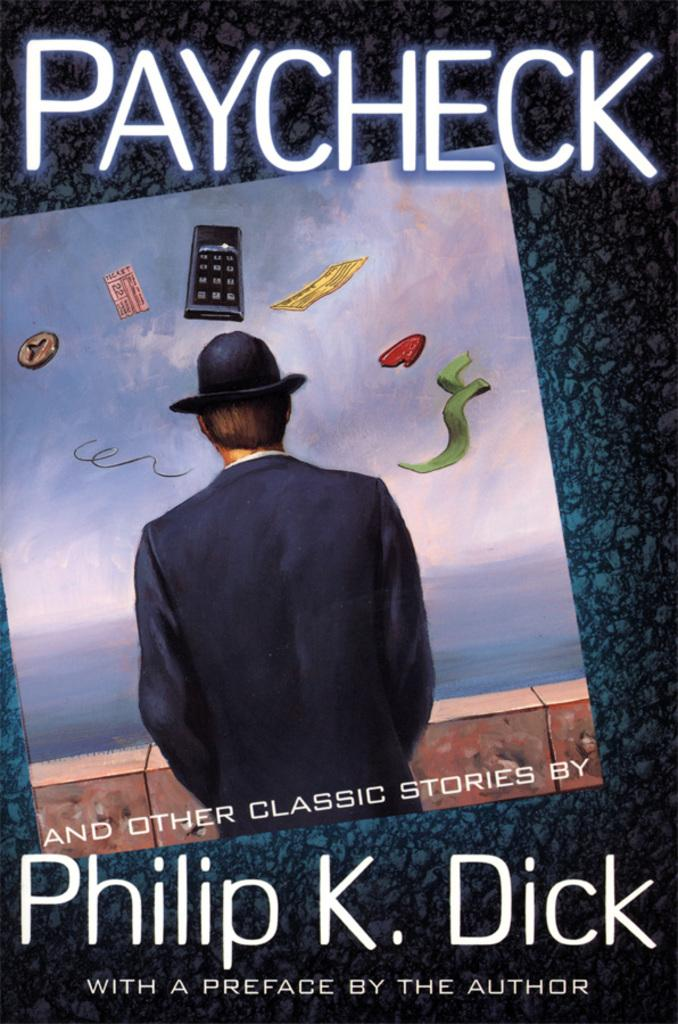<image>
Create a compact narrative representing the image presented. The cover of a book by Philip K. Dick 